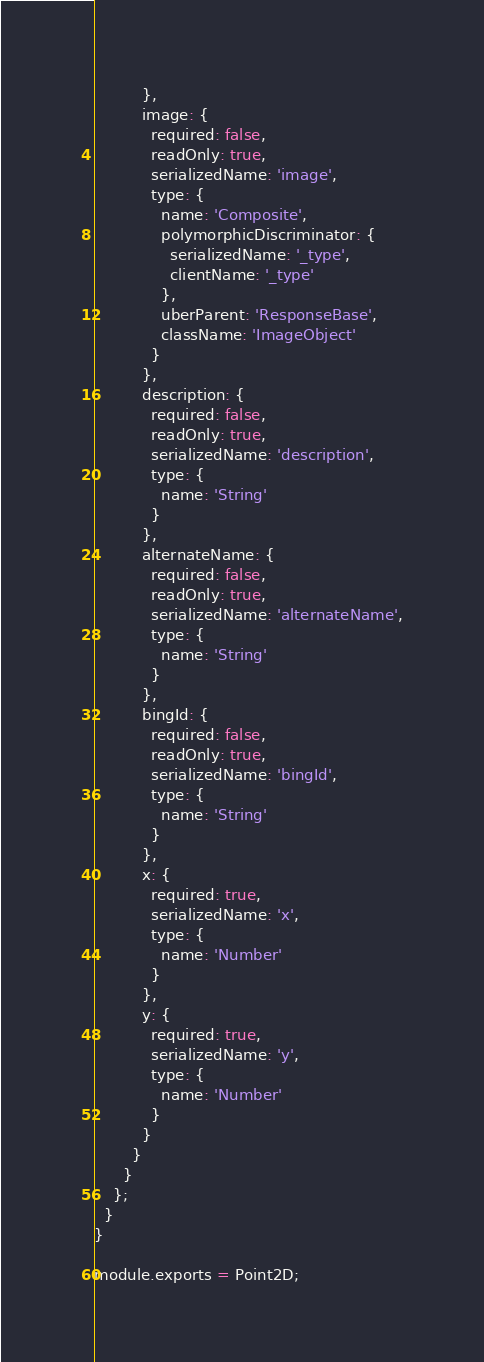Convert code to text. <code><loc_0><loc_0><loc_500><loc_500><_JavaScript_>          },
          image: {
            required: false,
            readOnly: true,
            serializedName: 'image',
            type: {
              name: 'Composite',
              polymorphicDiscriminator: {
                serializedName: '_type',
                clientName: '_type'
              },
              uberParent: 'ResponseBase',
              className: 'ImageObject'
            }
          },
          description: {
            required: false,
            readOnly: true,
            serializedName: 'description',
            type: {
              name: 'String'
            }
          },
          alternateName: {
            required: false,
            readOnly: true,
            serializedName: 'alternateName',
            type: {
              name: 'String'
            }
          },
          bingId: {
            required: false,
            readOnly: true,
            serializedName: 'bingId',
            type: {
              name: 'String'
            }
          },
          x: {
            required: true,
            serializedName: 'x',
            type: {
              name: 'Number'
            }
          },
          y: {
            required: true,
            serializedName: 'y',
            type: {
              name: 'Number'
            }
          }
        }
      }
    };
  }
}

module.exports = Point2D;
</code> 